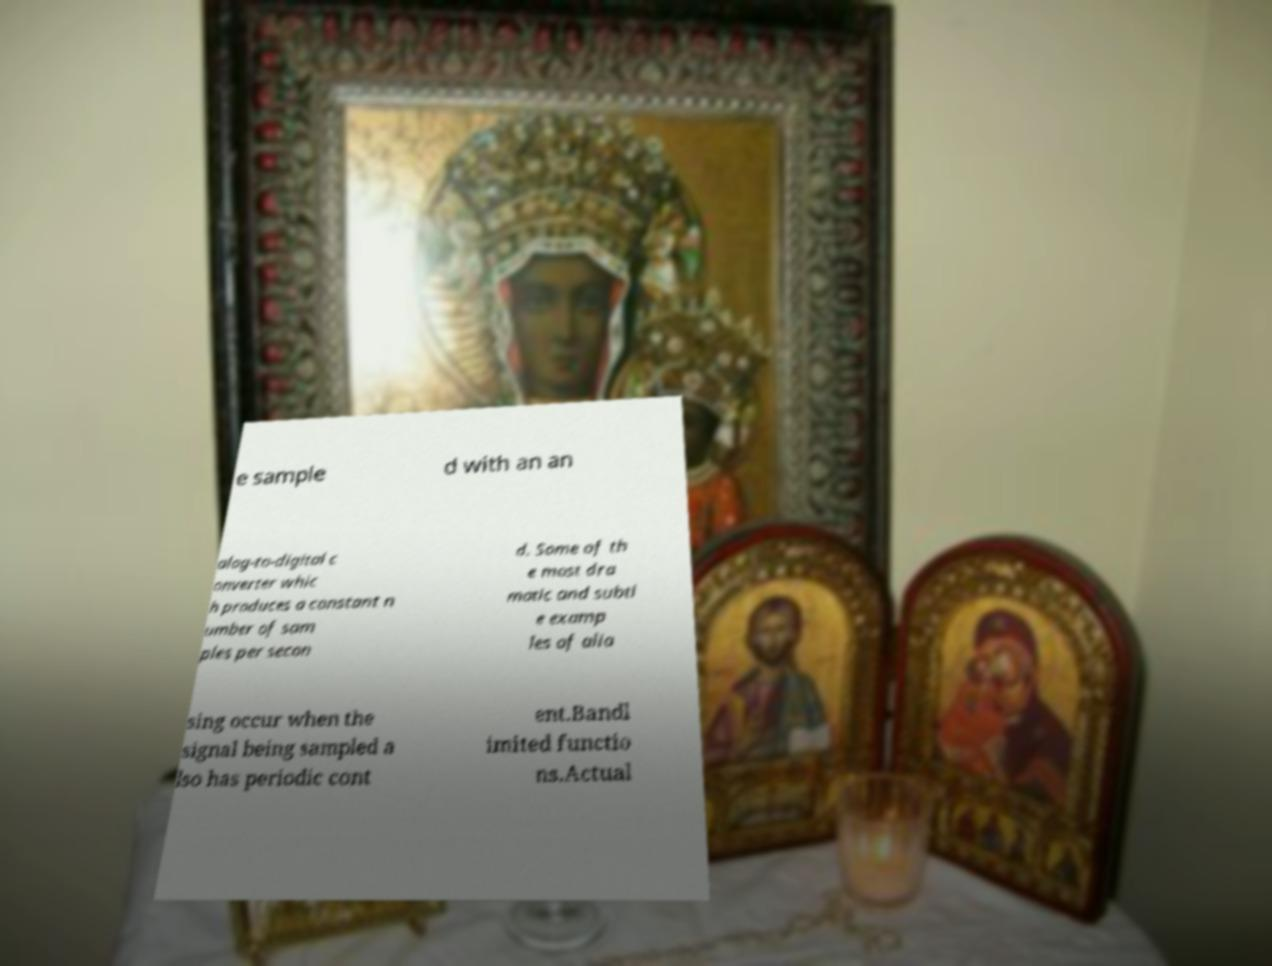I need the written content from this picture converted into text. Can you do that? e sample d with an an alog-to-digital c onverter whic h produces a constant n umber of sam ples per secon d. Some of th e most dra matic and subtl e examp les of alia sing occur when the signal being sampled a lso has periodic cont ent.Bandl imited functio ns.Actual 